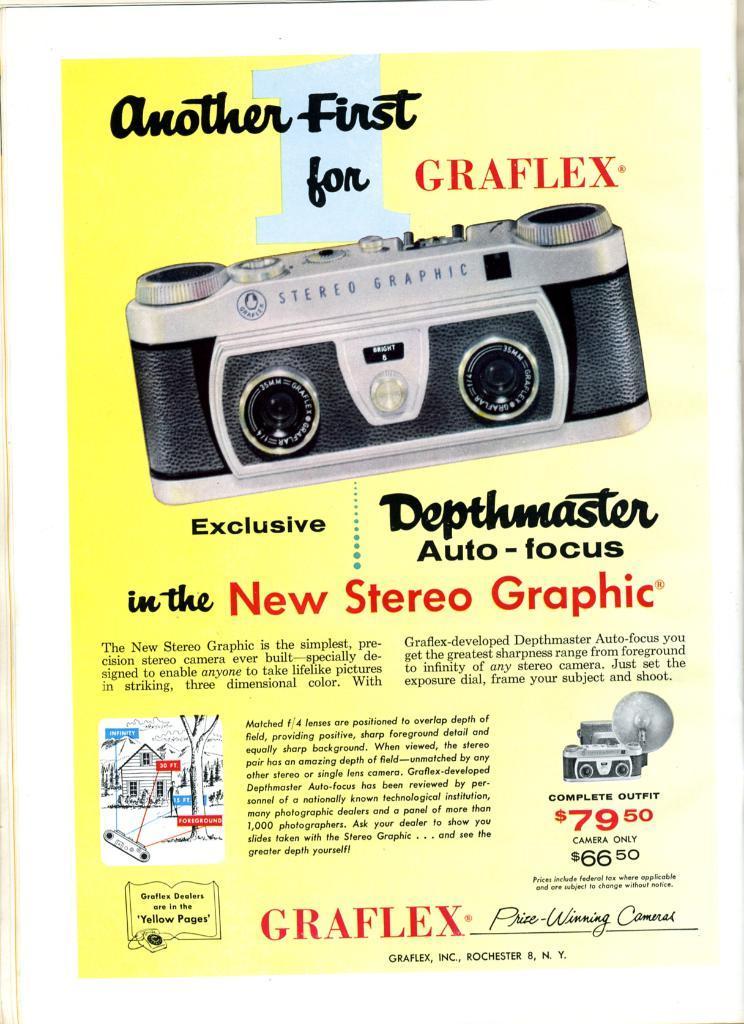Describe this image in one or two sentences. It is an edited image,it is the advertisement page of a device,the name of the device and the cost are mentioned in the page. 